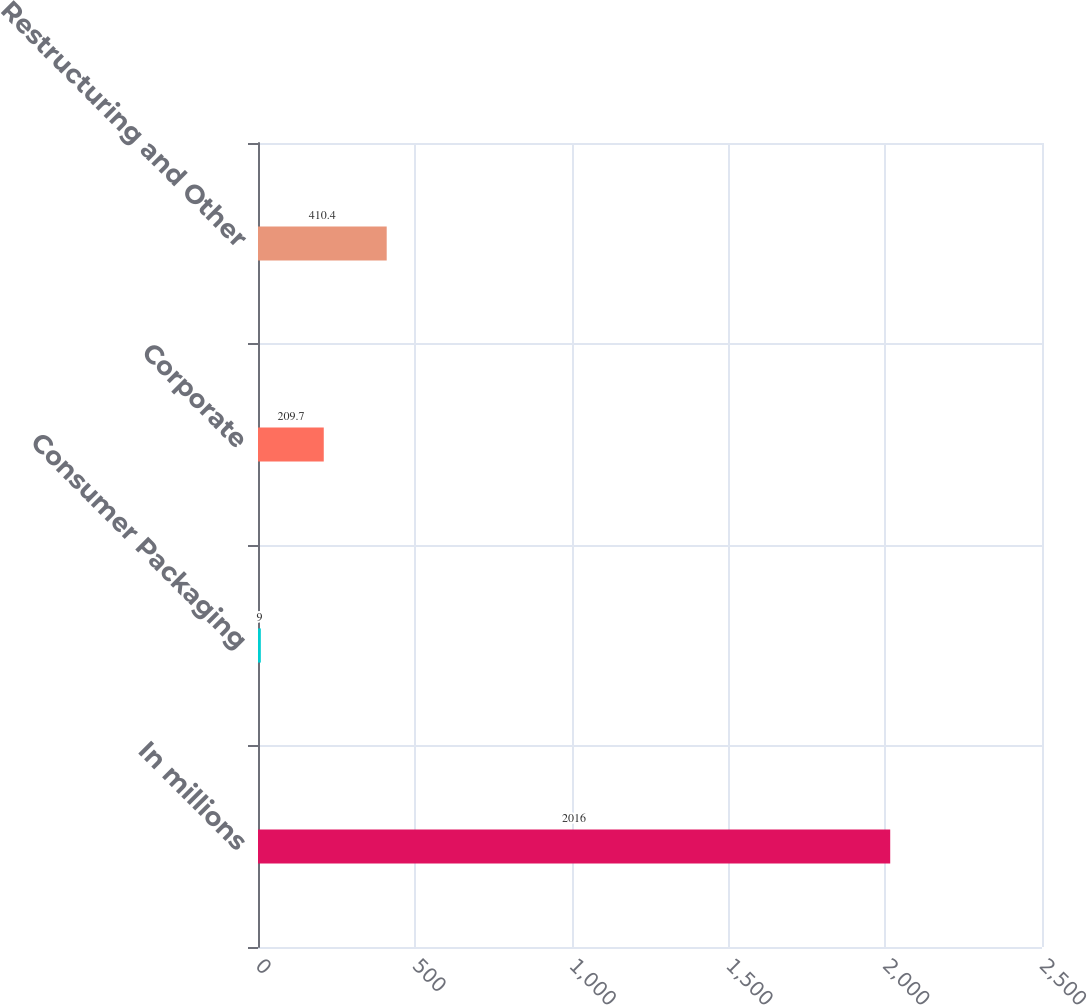Convert chart to OTSL. <chart><loc_0><loc_0><loc_500><loc_500><bar_chart><fcel>In millions<fcel>Consumer Packaging<fcel>Corporate<fcel>Restructuring and Other<nl><fcel>2016<fcel>9<fcel>209.7<fcel>410.4<nl></chart> 